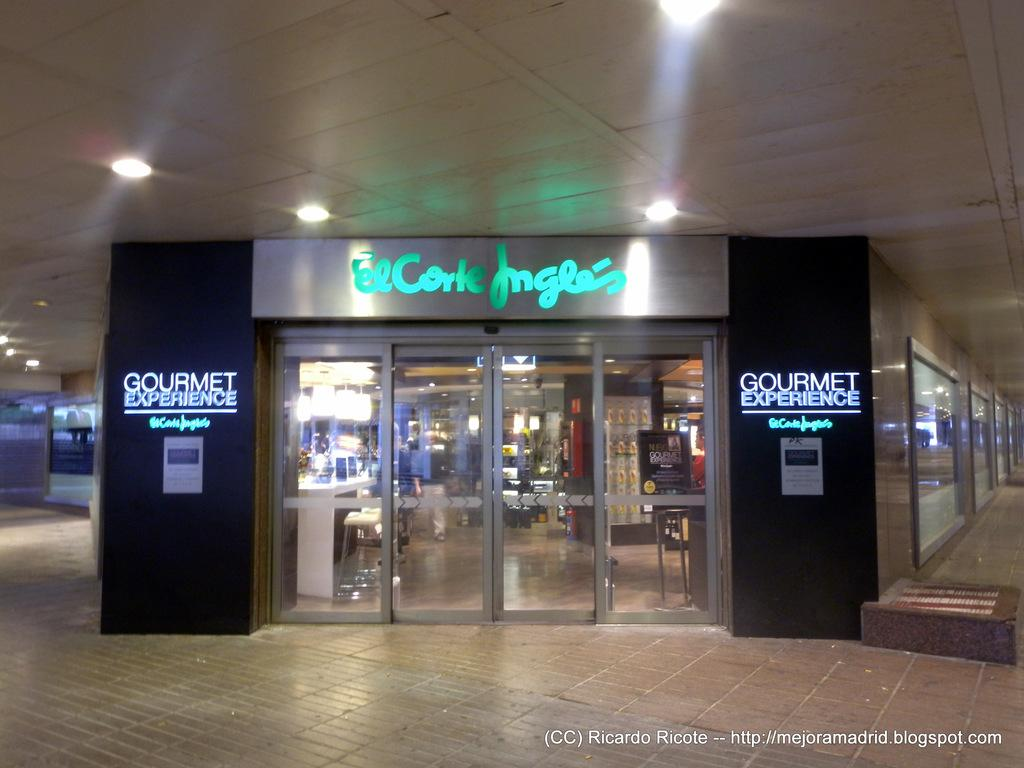What type of establishment is shown in the image? There is a store in the image. What feature can be seen on the store's entrance? The store has a glass door. What type of lighting is present in the store? There are lights over the ceiling in the store. What type of government is being discussed in the store? There is no discussion of government in the image; it shows a store with a glass door and ceiling lights. 